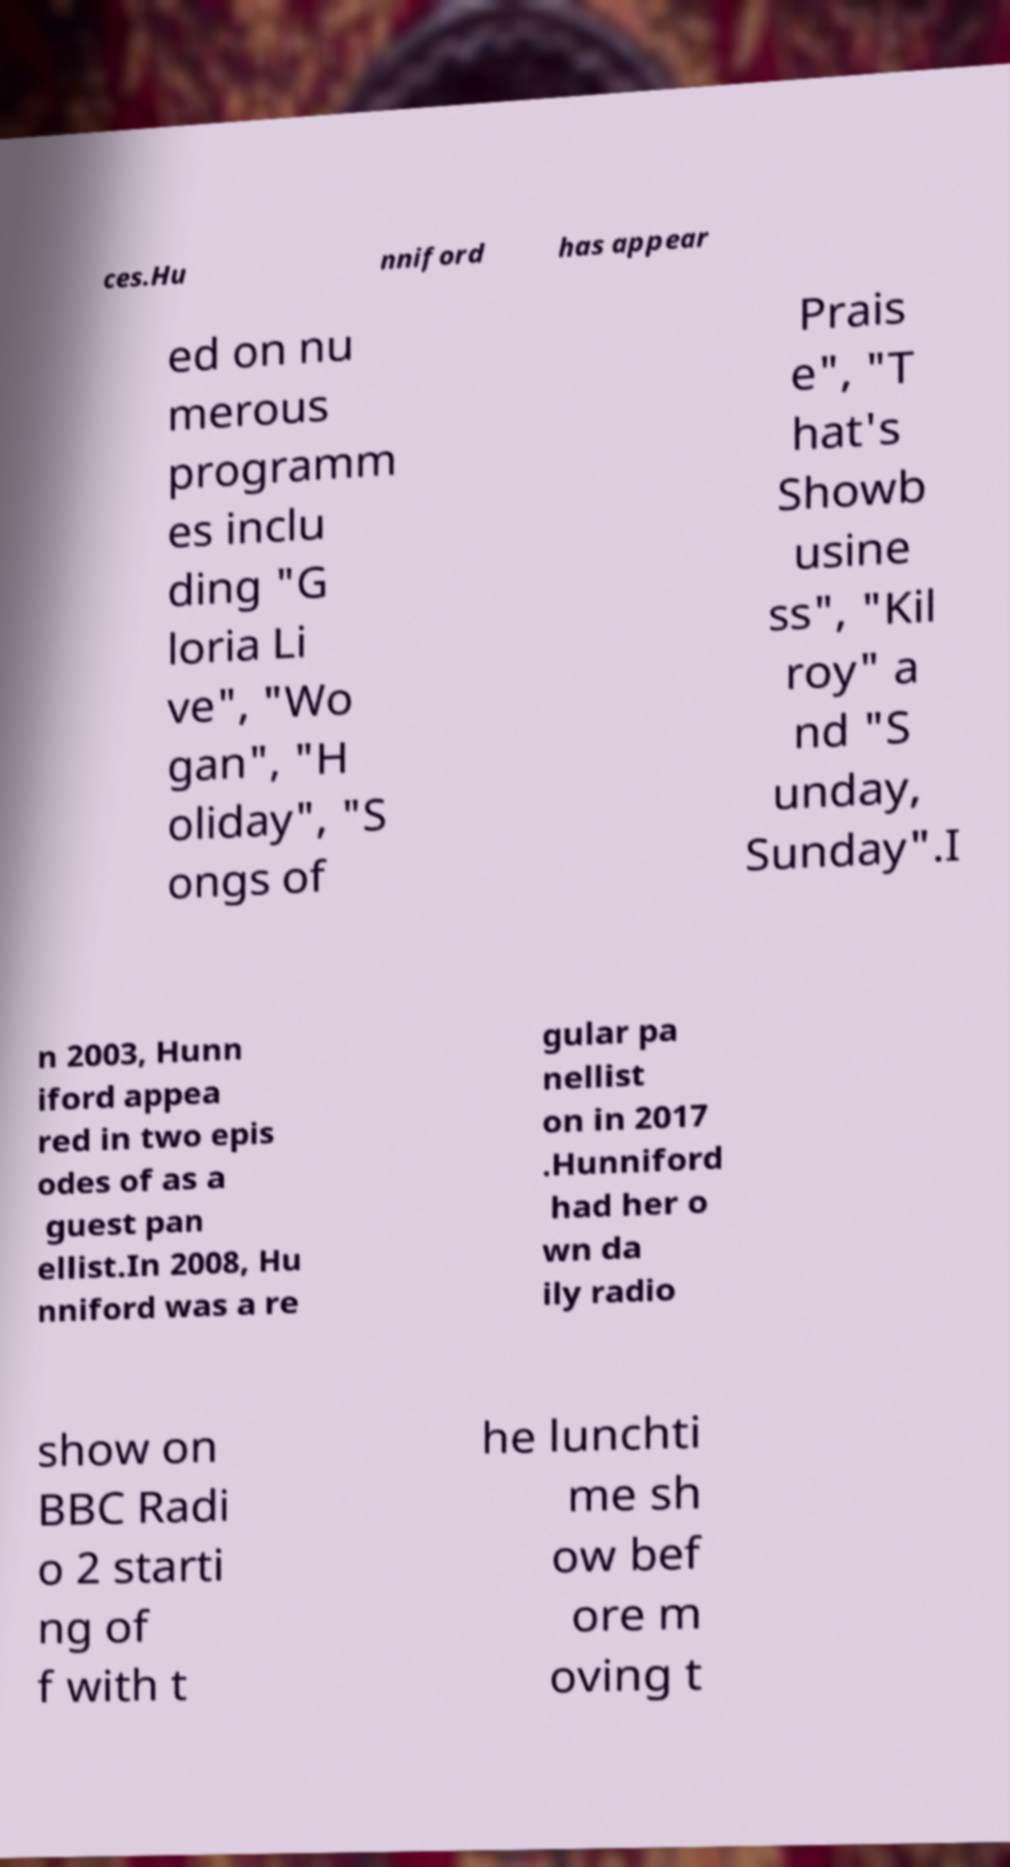Please identify and transcribe the text found in this image. ces.Hu nniford has appear ed on nu merous programm es inclu ding "G loria Li ve", "Wo gan", "H oliday", "S ongs of Prais e", "T hat's Showb usine ss", "Kil roy" a nd "S unday, Sunday".I n 2003, Hunn iford appea red in two epis odes of as a guest pan ellist.In 2008, Hu nniford was a re gular pa nellist on in 2017 .Hunniford had her o wn da ily radio show on BBC Radi o 2 starti ng of f with t he lunchti me sh ow bef ore m oving t 